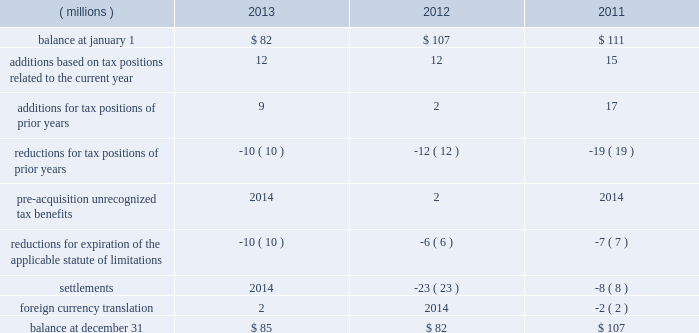52 2013 ppg annual report and form 10-k repatriation of undistributed earnings of non-u.s .
Subsidiaries as of december 31 , 2013 and december 31 , 2012 would have resulted in a u.s .
Tax cost of approximately $ 250 million and $ 110 million , respectively .
The company files federal , state and local income tax returns in numerous domestic and foreign jurisdictions .
In most tax jurisdictions , returns are subject to examination by the relevant tax authorities for a number of years after the returns have been filed .
The company is no longer subject to examinations by tax authorities in any major tax jurisdiction for years before 2006 .
Additionally , the internal revenue service has completed its examination of the company 2019s u.s .
Federal income tax returns filed for years through 2010 .
The examination of the company 2019s u.s .
Federal income tax return for 2011 is currently underway and is expected to be finalized during 2014 .
A reconciliation of the total amounts of unrecognized tax benefits ( excluding interest and penalties ) as of december 31 follows: .
The company expects that any reasonably possible change in the amount of unrecognized tax benefits in the next 12 months would not be significant .
The total amount of unrecognized tax benefits that , if recognized , would affect the effective tax rate was $ 81 million as of december 31 , 2013 .
The company recognizes accrued interest and penalties related to unrecognized tax benefits in income tax expense .
As of december 31 , 2013 , 2012 and 2011 , the company had liabilities for estimated interest and penalties on unrecognized tax benefits of $ 9 million , $ 10 million and $ 15 million , respectively .
The company recognized $ 2 million and $ 5 million of income in 2013 and 2012 , respectively , related to the reduction of estimated interest and penalties .
The company recognized no income or expense for estimated interest and penalties during the year ended december 31 , 2011 .
13 .
Pensions and other postretirement benefits defined benefit plans ppg has defined benefit pension plans that cover certain employees worldwide .
The principal defined benefit pension plans are those in the u.s. , canada , the netherlands and the u.k .
Which , in the aggregate represent approximately 91% ( 91 % ) of the projected benefit obligation at december 31 , 2013 , of which the u.s .
Defined benefit pension plans represent the majority .
Ppg also sponsors welfare benefit plans that provide postretirement medical and life insurance benefits for certain u.s .
And canadian employees and their dependents .
These programs require retiree contributions based on retiree-selected coverage levels for certain retirees and their dependents and provide for sharing of future benefit cost increases between ppg and participants based on management discretion .
The company has the right to modify or terminate certain of these benefit plans in the future .
Salaried and certain hourly employees in the u.s .
Hired on or after october 1 , 2004 , or rehired on or after october 1 , 2012 are not eligible for postretirement medical benefits .
Salaried employees in the u.s .
Hired , rehired or transferred to salaried status on or after january 1 , 2006 , and certain u.s .
Hourly employees hired in 2006 or thereafter are eligible to participate in a defined contribution retirement plan .
These employees are not eligible for defined benefit pension plan benefits .
Plan design changes in january 2011 , the company approved an amendment to one of its u.s .
Defined benefit pension plans that represented about 77% ( 77 % ) of the total u.s .
Projected benefit obligation at december 31 , 2011 .
Depending upon the affected employee's combined age and years of service to ppg , this change resulted in certain employees no longer accruing benefits under this plan as of december 31 , 2011 , while the remaining employees will no longer accrue benefits under this plan as of december 31 , 2020 .
The affected employees will participate in the company 2019s defined contribution retirement plan from the date their benefit under the defined benefit plan is frozen .
The company remeasured the projected benefit obligation of this amended plan , which lowered 2011 pension expense by approximately $ 12 million .
The company made similar changes to certain other u.s .
Defined benefit pension plans in 2011 .
The company recognized a curtailment loss and special termination benefits associated with these plan amendments of $ 5 million in 2011 .
The company plans to continue reviewing and potentially changing other ppg defined benefit plans in the future .
Separation and merger of commodity chemicals business on january 28 , 2013 , ppg completed the separation of its commodity chemicals business and the merger of the subsidiary holding the ppg commodity chemicals business with a subsidiary of georgia gulf , as discussed in note 22 , 201cseparation and merger transaction . 201d ppg transferred the defined benefit pension plan and other postretirement benefit liabilities for the affected employees in the u.s. , canada , and taiwan in the separation resulting in a net partial settlement loss of $ 33 million notes to the consolidated financial statements .
What is the average increase in the balance of unrecognized tax benefits from 2011 to 2013? 
Computations: (((82 / 107) + (85 / 82)) / 2)
Answer: 0.90147. 